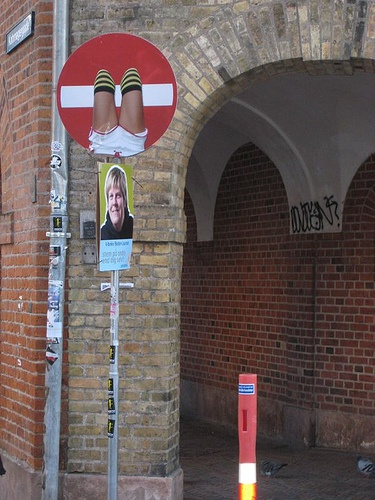Describe the objects in this image and their specific colors. I can see various objects in this image with different colors. 